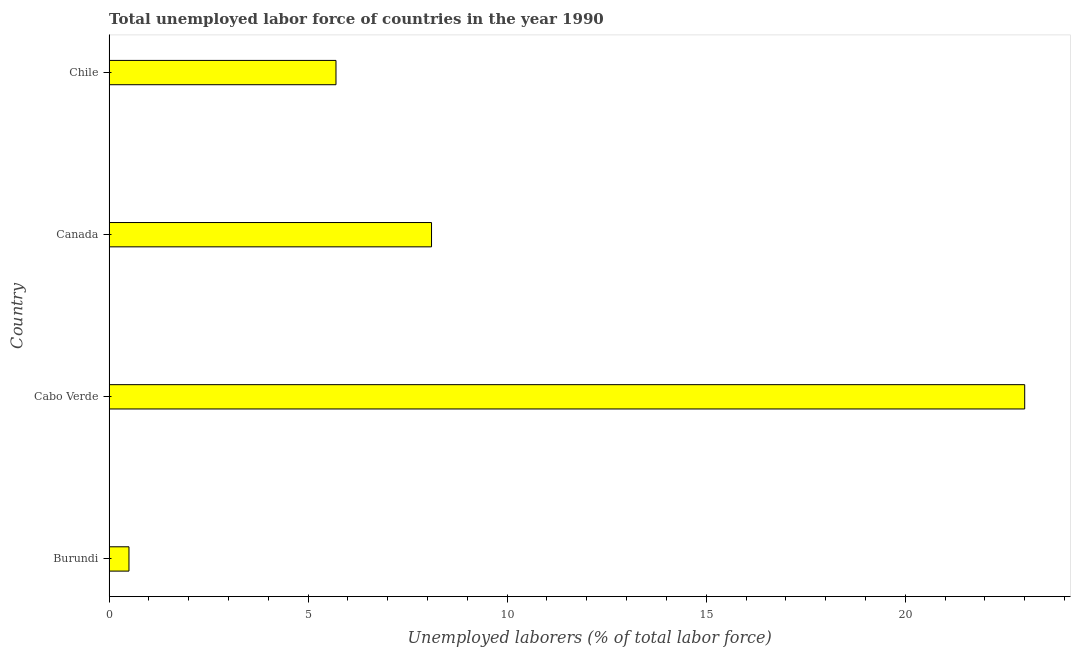Does the graph contain any zero values?
Your answer should be very brief. No. What is the title of the graph?
Keep it short and to the point. Total unemployed labor force of countries in the year 1990. What is the label or title of the X-axis?
Ensure brevity in your answer.  Unemployed laborers (% of total labor force). What is the label or title of the Y-axis?
Offer a terse response. Country. What is the total unemployed labour force in Cabo Verde?
Offer a very short reply. 23. Across all countries, what is the maximum total unemployed labour force?
Keep it short and to the point. 23. Across all countries, what is the minimum total unemployed labour force?
Ensure brevity in your answer.  0.5. In which country was the total unemployed labour force maximum?
Offer a very short reply. Cabo Verde. In which country was the total unemployed labour force minimum?
Keep it short and to the point. Burundi. What is the sum of the total unemployed labour force?
Provide a succinct answer. 37.3. What is the difference between the total unemployed labour force in Cabo Verde and Chile?
Offer a very short reply. 17.3. What is the average total unemployed labour force per country?
Your response must be concise. 9.32. What is the median total unemployed labour force?
Your answer should be very brief. 6.9. In how many countries, is the total unemployed labour force greater than 9 %?
Keep it short and to the point. 1. What is the ratio of the total unemployed labour force in Canada to that in Chile?
Your answer should be compact. 1.42. Is the total unemployed labour force in Cabo Verde less than that in Canada?
Provide a short and direct response. No. Is the difference between the total unemployed labour force in Burundi and Chile greater than the difference between any two countries?
Your answer should be compact. No. What is the difference between the highest and the second highest total unemployed labour force?
Your answer should be compact. 14.9. What is the difference between the highest and the lowest total unemployed labour force?
Ensure brevity in your answer.  22.5. In how many countries, is the total unemployed labour force greater than the average total unemployed labour force taken over all countries?
Your answer should be very brief. 1. Are all the bars in the graph horizontal?
Ensure brevity in your answer.  Yes. How many countries are there in the graph?
Provide a short and direct response. 4. What is the difference between two consecutive major ticks on the X-axis?
Keep it short and to the point. 5. What is the Unemployed laborers (% of total labor force) in Cabo Verde?
Offer a terse response. 23. What is the Unemployed laborers (% of total labor force) in Canada?
Ensure brevity in your answer.  8.1. What is the Unemployed laborers (% of total labor force) in Chile?
Your answer should be compact. 5.7. What is the difference between the Unemployed laborers (% of total labor force) in Burundi and Cabo Verde?
Ensure brevity in your answer.  -22.5. What is the difference between the Unemployed laborers (% of total labor force) in Burundi and Chile?
Keep it short and to the point. -5.2. What is the difference between the Unemployed laborers (% of total labor force) in Canada and Chile?
Offer a terse response. 2.4. What is the ratio of the Unemployed laborers (% of total labor force) in Burundi to that in Cabo Verde?
Your answer should be very brief. 0.02. What is the ratio of the Unemployed laborers (% of total labor force) in Burundi to that in Canada?
Ensure brevity in your answer.  0.06. What is the ratio of the Unemployed laborers (% of total labor force) in Burundi to that in Chile?
Keep it short and to the point. 0.09. What is the ratio of the Unemployed laborers (% of total labor force) in Cabo Verde to that in Canada?
Offer a very short reply. 2.84. What is the ratio of the Unemployed laborers (% of total labor force) in Cabo Verde to that in Chile?
Offer a very short reply. 4.04. What is the ratio of the Unemployed laborers (% of total labor force) in Canada to that in Chile?
Give a very brief answer. 1.42. 